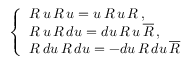<formula> <loc_0><loc_0><loc_500><loc_500>\left \{ \begin{array} { l } { R \, u \, R \, u = u \, R \, u \, R \, , } \\ { { R \, u \, R \, d u = d u \, R \, u \, \overline { R } \, , } } \\ { { R \, d u \, R \, d u = - d u \, R \, d u \, \overline { R } } } \end{array}</formula> 